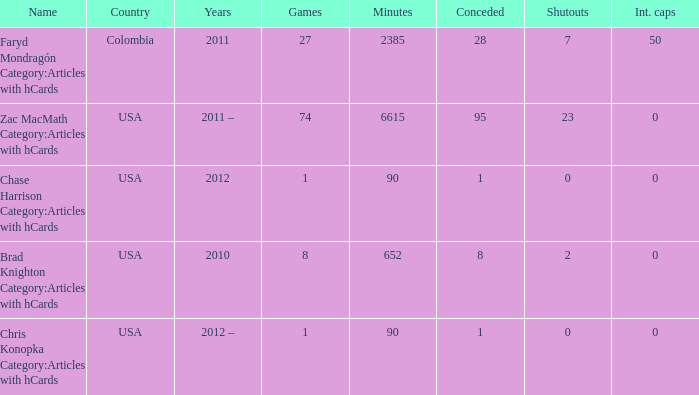Parse the full table. {'header': ['Name', 'Country', 'Years', 'Games', 'Minutes', 'Conceded', 'Shutouts', 'Int. caps'], 'rows': [['Faryd Mondragón Category:Articles with hCards', 'Colombia', '2011', '27', '2385', '28', '7', '50'], ['Zac MacMath Category:Articles with hCards', 'USA', '2011 –', '74', '6615', '95', '23', '0'], ['Chase Harrison Category:Articles with hCards', 'USA', '2012', '1', '90', '1', '0', '0'], ['Brad Knighton Category:Articles with hCards', 'USA', '2010', '8', '652', '8', '2', '0'], ['Chris Konopka Category:Articles with hCards', 'USA', '2012 –', '1', '90', '1', '0', '0']]} When chase harrison category:articles with hcards is the name what is the year? 2012.0. 